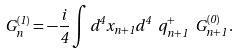<formula> <loc_0><loc_0><loc_500><loc_500>G ^ { ( 1 ) } _ { n } = - \frac { i } { 4 } \int d ^ { 4 } x _ { n + 1 } d ^ { 4 } \ q ^ { + } _ { n + 1 } \ G ^ { ( 0 ) } _ { n + 1 } \, .</formula> 